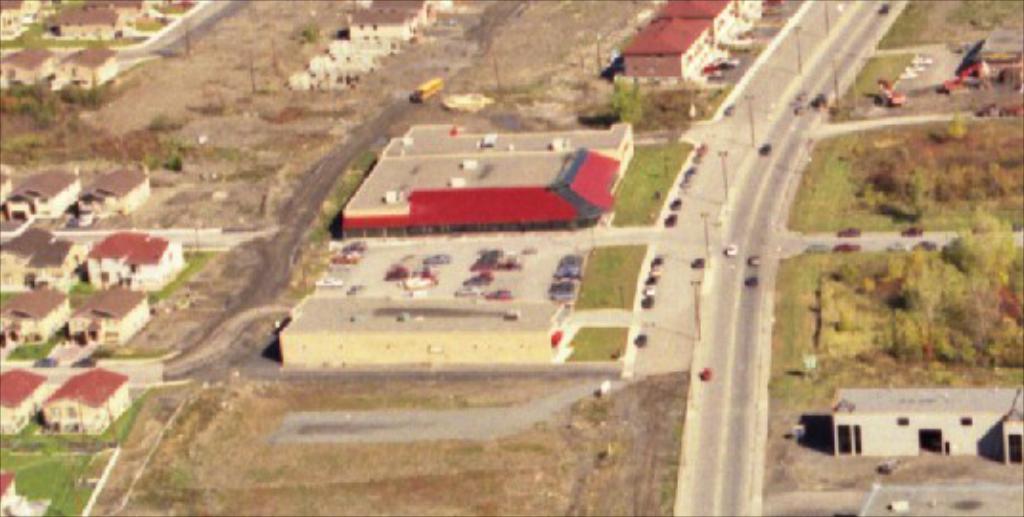Can you describe this image briefly? In this picture I can see number of buildings, trees, poles and cars. I can also see the roads and I can see the grass. 